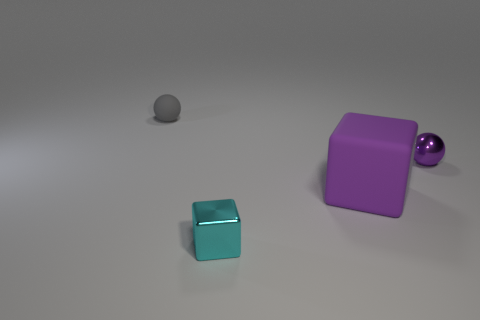Can you describe the lighting and mood evoked by the image? The image portrays a soft, diffused lighting that gives it a calm and serene atmosphere. The muted tones and the simplicity of the objects against the neutral background can evoke a sense of minimalism and tranquillity. What could be the purpose of arranging these objects like this? The arrangement of the objects might be artistic, aiming to highlight the contrast in shapes and colors, or it could be a setup for demonstrating principles of physics or photography, such as reflection, shadows, or color theory. 